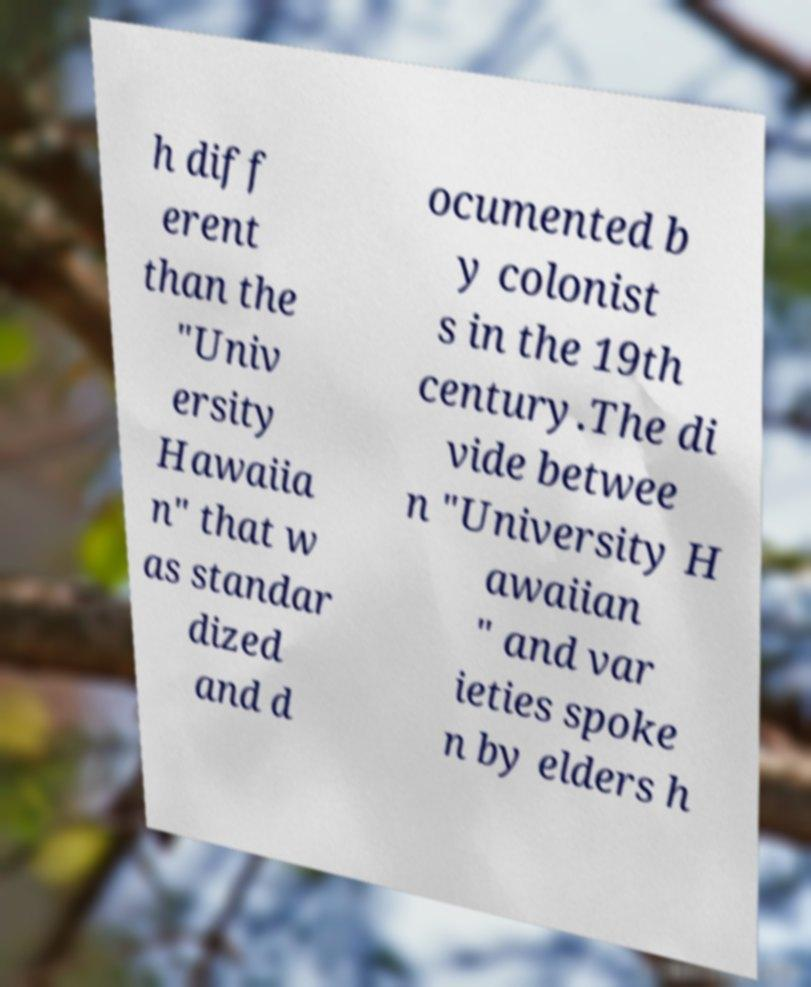What messages or text are displayed in this image? I need them in a readable, typed format. h diff erent than the "Univ ersity Hawaiia n" that w as standar dized and d ocumented b y colonist s in the 19th century.The di vide betwee n "University H awaiian " and var ieties spoke n by elders h 